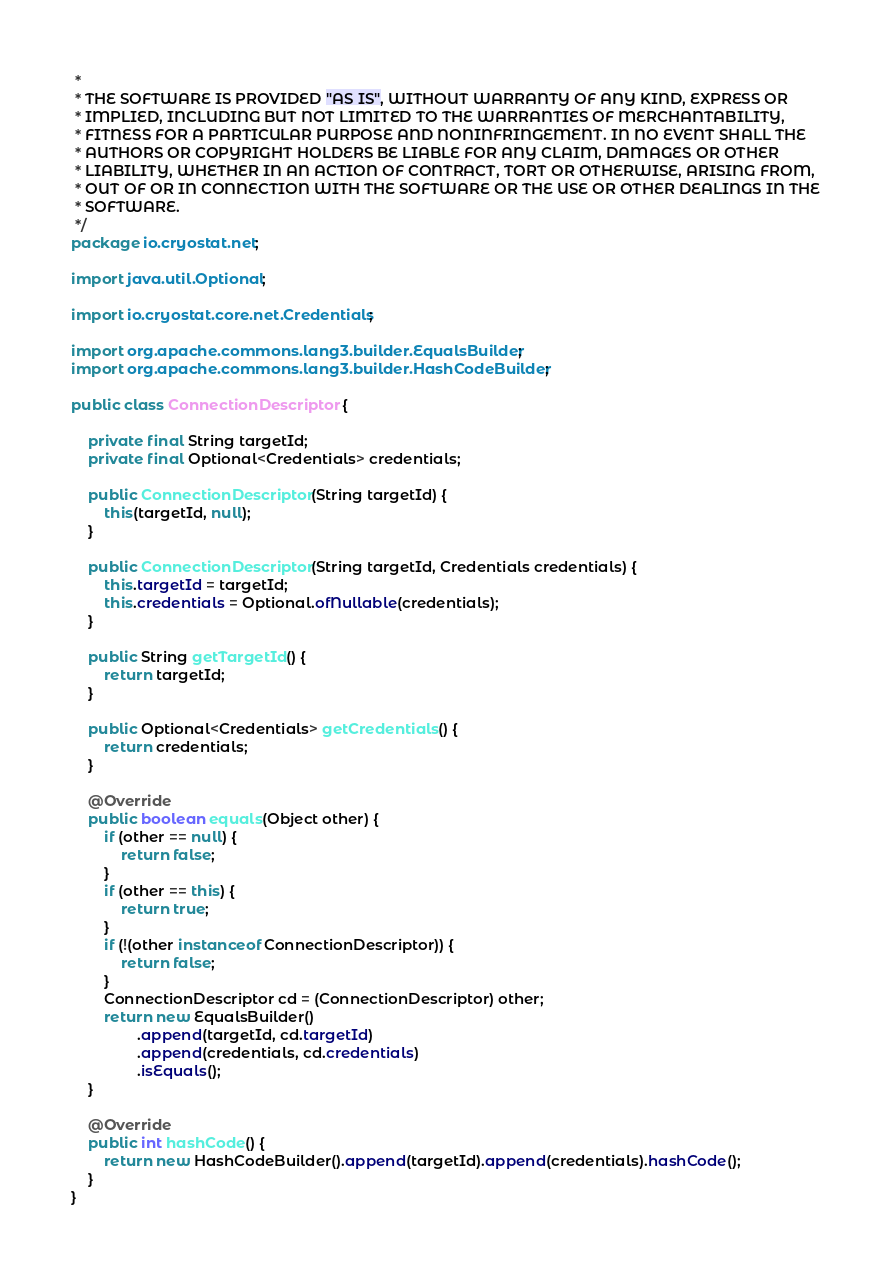Convert code to text. <code><loc_0><loc_0><loc_500><loc_500><_Java_> *
 * THE SOFTWARE IS PROVIDED "AS IS", WITHOUT WARRANTY OF ANY KIND, EXPRESS OR
 * IMPLIED, INCLUDING BUT NOT LIMITED TO THE WARRANTIES OF MERCHANTABILITY,
 * FITNESS FOR A PARTICULAR PURPOSE AND NONINFRINGEMENT. IN NO EVENT SHALL THE
 * AUTHORS OR COPYRIGHT HOLDERS BE LIABLE FOR ANY CLAIM, DAMAGES OR OTHER
 * LIABILITY, WHETHER IN AN ACTION OF CONTRACT, TORT OR OTHERWISE, ARISING FROM,
 * OUT OF OR IN CONNECTION WITH THE SOFTWARE OR THE USE OR OTHER DEALINGS IN THE
 * SOFTWARE.
 */
package io.cryostat.net;

import java.util.Optional;

import io.cryostat.core.net.Credentials;

import org.apache.commons.lang3.builder.EqualsBuilder;
import org.apache.commons.lang3.builder.HashCodeBuilder;

public class ConnectionDescriptor {

    private final String targetId;
    private final Optional<Credentials> credentials;

    public ConnectionDescriptor(String targetId) {
        this(targetId, null);
    }

    public ConnectionDescriptor(String targetId, Credentials credentials) {
        this.targetId = targetId;
        this.credentials = Optional.ofNullable(credentials);
    }

    public String getTargetId() {
        return targetId;
    }

    public Optional<Credentials> getCredentials() {
        return credentials;
    }

    @Override
    public boolean equals(Object other) {
        if (other == null) {
            return false;
        }
        if (other == this) {
            return true;
        }
        if (!(other instanceof ConnectionDescriptor)) {
            return false;
        }
        ConnectionDescriptor cd = (ConnectionDescriptor) other;
        return new EqualsBuilder()
                .append(targetId, cd.targetId)
                .append(credentials, cd.credentials)
                .isEquals();
    }

    @Override
    public int hashCode() {
        return new HashCodeBuilder().append(targetId).append(credentials).hashCode();
    }
}
</code> 